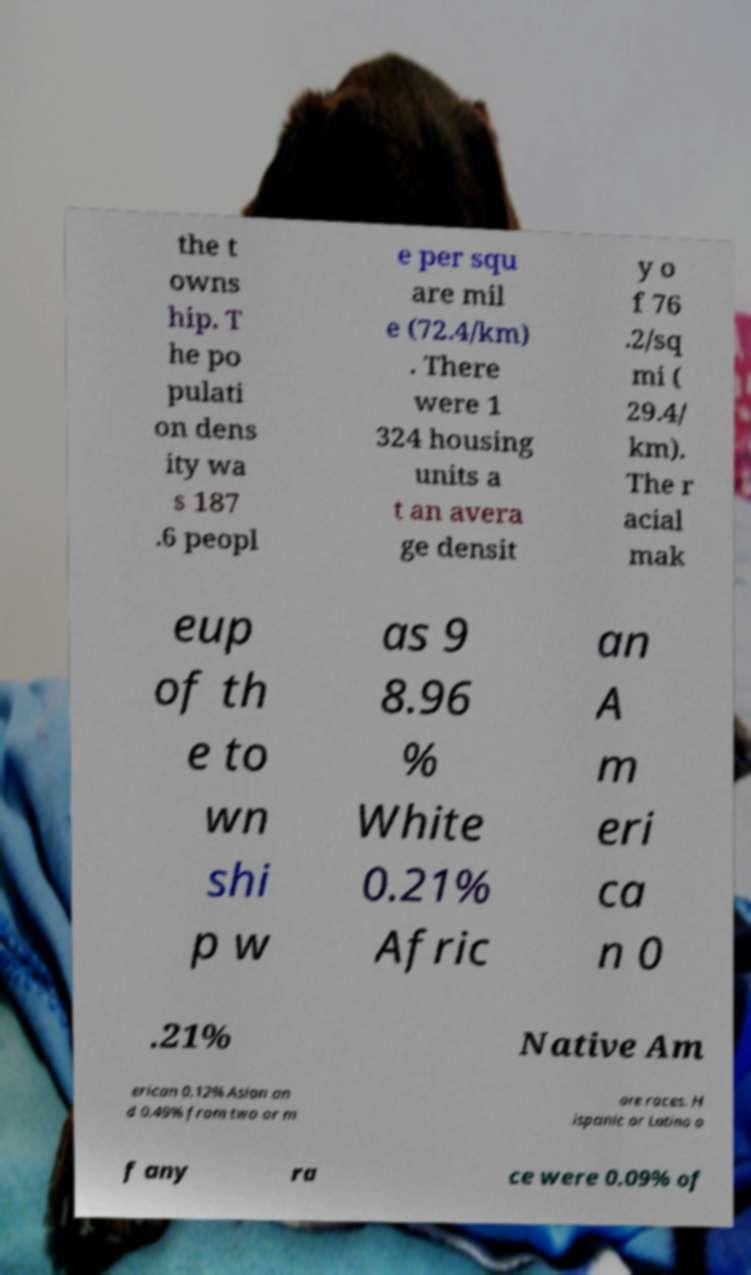I need the written content from this picture converted into text. Can you do that? the t owns hip. T he po pulati on dens ity wa s 187 .6 peopl e per squ are mil e (72.4/km) . There were 1 324 housing units a t an avera ge densit y o f 76 .2/sq mi ( 29.4/ km). The r acial mak eup of th e to wn shi p w as 9 8.96 % White 0.21% Afric an A m eri ca n 0 .21% Native Am erican 0.12% Asian an d 0.49% from two or m ore races. H ispanic or Latino o f any ra ce were 0.09% of 